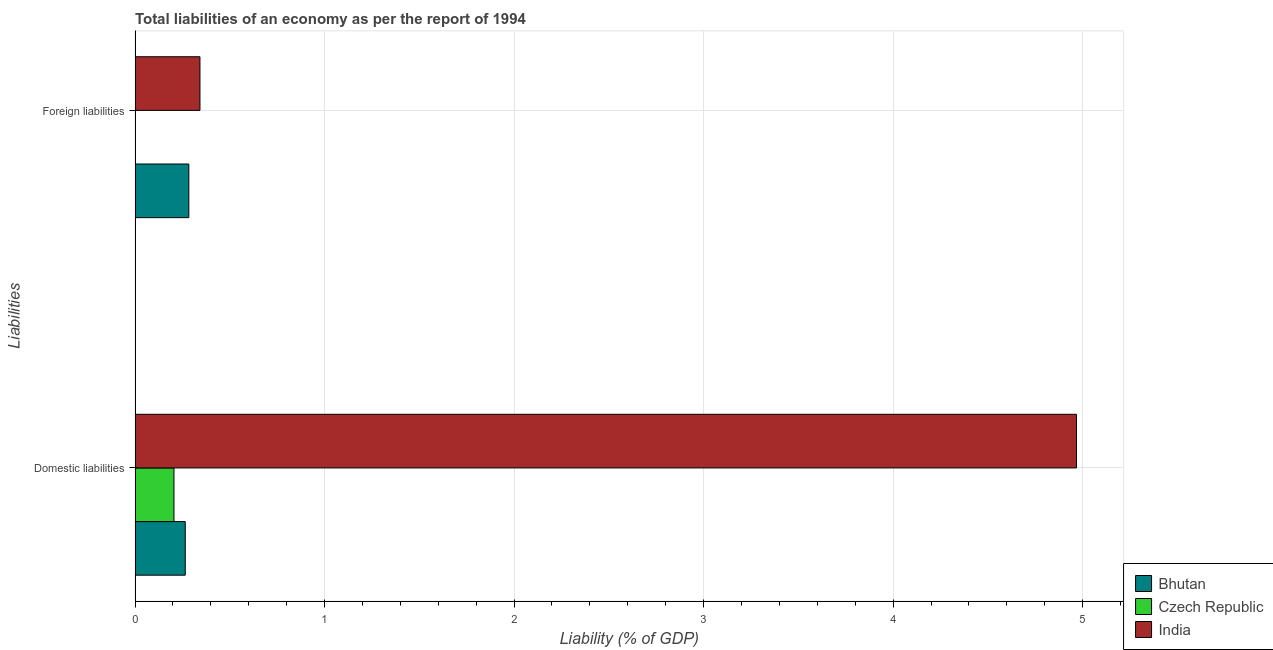How many bars are there on the 1st tick from the top?
Offer a terse response. 2. What is the label of the 1st group of bars from the top?
Provide a succinct answer. Foreign liabilities. What is the incurrence of foreign liabilities in India?
Your answer should be compact. 0.34. Across all countries, what is the maximum incurrence of domestic liabilities?
Give a very brief answer. 4.97. What is the total incurrence of domestic liabilities in the graph?
Your response must be concise. 5.44. What is the difference between the incurrence of foreign liabilities in India and that in Bhutan?
Ensure brevity in your answer.  0.06. What is the difference between the incurrence of domestic liabilities in India and the incurrence of foreign liabilities in Bhutan?
Offer a terse response. 4.68. What is the average incurrence of domestic liabilities per country?
Offer a terse response. 1.81. What is the difference between the incurrence of domestic liabilities and incurrence of foreign liabilities in Bhutan?
Provide a short and direct response. -0.02. In how many countries, is the incurrence of foreign liabilities greater than 4.4 %?
Your answer should be compact. 0. What is the ratio of the incurrence of domestic liabilities in India to that in Bhutan?
Keep it short and to the point. 18.76. Is the incurrence of domestic liabilities in Bhutan less than that in Czech Republic?
Offer a terse response. No. In how many countries, is the incurrence of domestic liabilities greater than the average incurrence of domestic liabilities taken over all countries?
Keep it short and to the point. 1. How many countries are there in the graph?
Provide a short and direct response. 3. What is the difference between two consecutive major ticks on the X-axis?
Your response must be concise. 1. Are the values on the major ticks of X-axis written in scientific E-notation?
Provide a succinct answer. No. How many legend labels are there?
Make the answer very short. 3. How are the legend labels stacked?
Keep it short and to the point. Vertical. What is the title of the graph?
Your answer should be very brief. Total liabilities of an economy as per the report of 1994. Does "Benin" appear as one of the legend labels in the graph?
Provide a succinct answer. No. What is the label or title of the X-axis?
Offer a terse response. Liability (% of GDP). What is the label or title of the Y-axis?
Provide a short and direct response. Liabilities. What is the Liability (% of GDP) in Bhutan in Domestic liabilities?
Your answer should be compact. 0.26. What is the Liability (% of GDP) of Czech Republic in Domestic liabilities?
Make the answer very short. 0.21. What is the Liability (% of GDP) in India in Domestic liabilities?
Offer a very short reply. 4.97. What is the Liability (% of GDP) in Bhutan in Foreign liabilities?
Keep it short and to the point. 0.28. What is the Liability (% of GDP) of India in Foreign liabilities?
Your answer should be very brief. 0.34. Across all Liabilities, what is the maximum Liability (% of GDP) in Bhutan?
Your response must be concise. 0.28. Across all Liabilities, what is the maximum Liability (% of GDP) of Czech Republic?
Offer a very short reply. 0.21. Across all Liabilities, what is the maximum Liability (% of GDP) in India?
Your answer should be compact. 4.97. Across all Liabilities, what is the minimum Liability (% of GDP) in Bhutan?
Keep it short and to the point. 0.26. Across all Liabilities, what is the minimum Liability (% of GDP) in India?
Offer a terse response. 0.34. What is the total Liability (% of GDP) in Bhutan in the graph?
Keep it short and to the point. 0.55. What is the total Liability (% of GDP) of Czech Republic in the graph?
Your response must be concise. 0.21. What is the total Liability (% of GDP) of India in the graph?
Provide a short and direct response. 5.31. What is the difference between the Liability (% of GDP) of Bhutan in Domestic liabilities and that in Foreign liabilities?
Your answer should be very brief. -0.02. What is the difference between the Liability (% of GDP) of India in Domestic liabilities and that in Foreign liabilities?
Your response must be concise. 4.63. What is the difference between the Liability (% of GDP) in Bhutan in Domestic liabilities and the Liability (% of GDP) in India in Foreign liabilities?
Your response must be concise. -0.08. What is the difference between the Liability (% of GDP) in Czech Republic in Domestic liabilities and the Liability (% of GDP) in India in Foreign liabilities?
Your answer should be compact. -0.14. What is the average Liability (% of GDP) of Bhutan per Liabilities?
Your answer should be compact. 0.27. What is the average Liability (% of GDP) of Czech Republic per Liabilities?
Ensure brevity in your answer.  0.1. What is the average Liability (% of GDP) in India per Liabilities?
Provide a short and direct response. 2.66. What is the difference between the Liability (% of GDP) in Bhutan and Liability (% of GDP) in Czech Republic in Domestic liabilities?
Keep it short and to the point. 0.06. What is the difference between the Liability (% of GDP) in Bhutan and Liability (% of GDP) in India in Domestic liabilities?
Offer a terse response. -4.7. What is the difference between the Liability (% of GDP) of Czech Republic and Liability (% of GDP) of India in Domestic liabilities?
Provide a succinct answer. -4.76. What is the difference between the Liability (% of GDP) of Bhutan and Liability (% of GDP) of India in Foreign liabilities?
Your answer should be very brief. -0.06. What is the ratio of the Liability (% of GDP) in Bhutan in Domestic liabilities to that in Foreign liabilities?
Ensure brevity in your answer.  0.93. What is the ratio of the Liability (% of GDP) of India in Domestic liabilities to that in Foreign liabilities?
Offer a terse response. 14.51. What is the difference between the highest and the second highest Liability (% of GDP) in Bhutan?
Provide a short and direct response. 0.02. What is the difference between the highest and the second highest Liability (% of GDP) in India?
Ensure brevity in your answer.  4.63. What is the difference between the highest and the lowest Liability (% of GDP) in Bhutan?
Provide a succinct answer. 0.02. What is the difference between the highest and the lowest Liability (% of GDP) in Czech Republic?
Ensure brevity in your answer.  0.21. What is the difference between the highest and the lowest Liability (% of GDP) in India?
Make the answer very short. 4.63. 